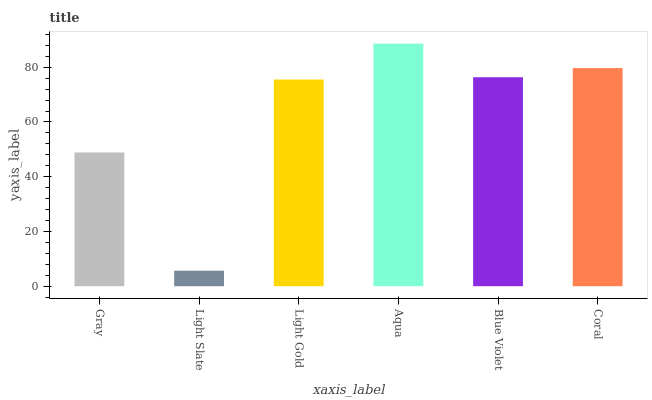Is Light Slate the minimum?
Answer yes or no. Yes. Is Aqua the maximum?
Answer yes or no. Yes. Is Light Gold the minimum?
Answer yes or no. No. Is Light Gold the maximum?
Answer yes or no. No. Is Light Gold greater than Light Slate?
Answer yes or no. Yes. Is Light Slate less than Light Gold?
Answer yes or no. Yes. Is Light Slate greater than Light Gold?
Answer yes or no. No. Is Light Gold less than Light Slate?
Answer yes or no. No. Is Blue Violet the high median?
Answer yes or no. Yes. Is Light Gold the low median?
Answer yes or no. Yes. Is Aqua the high median?
Answer yes or no. No. Is Aqua the low median?
Answer yes or no. No. 